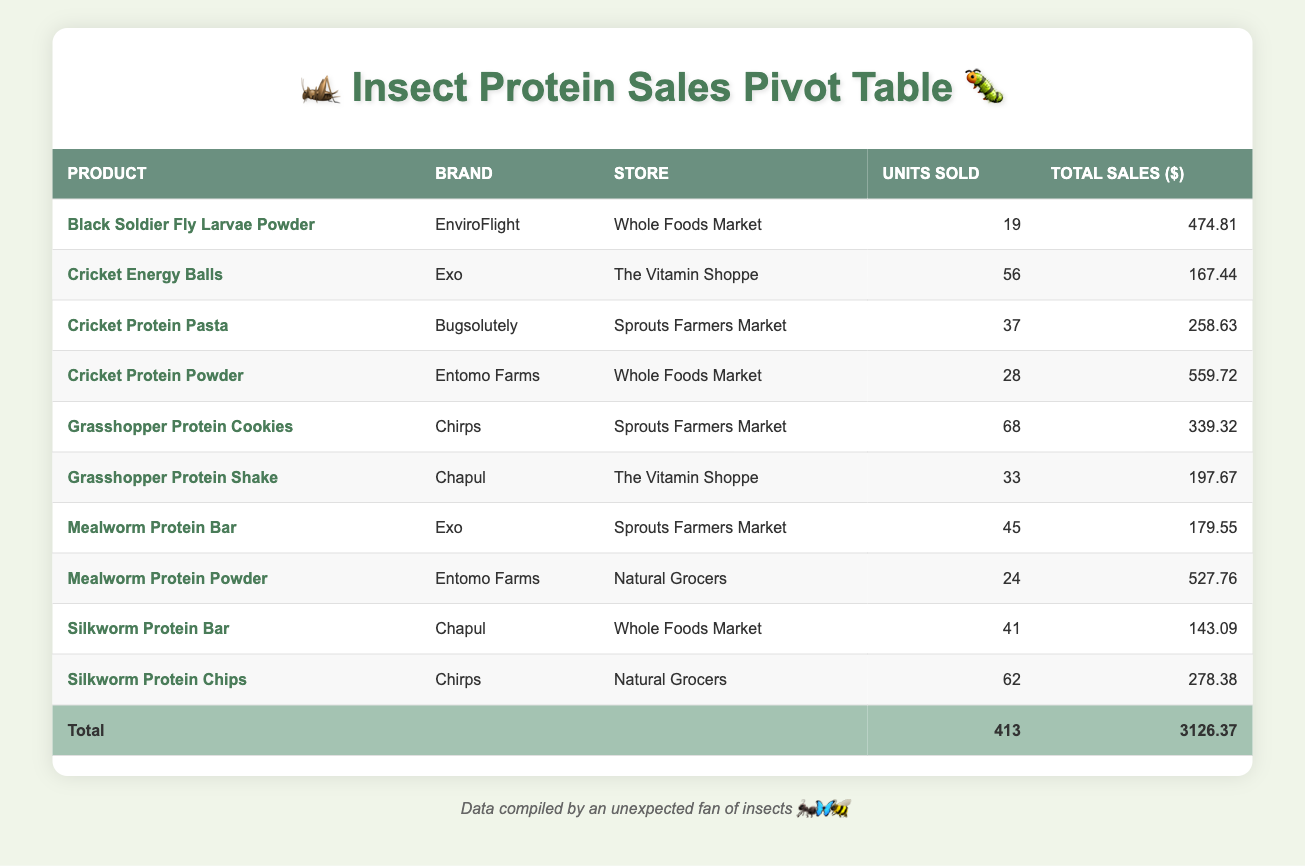What is the total sales amount for "Cricket Protein Powder"? The total sales figure for "Cricket Protein Powder" can be found directly in the table, where it states "Cricket Protein Powder" under the product column with its corresponding total sales of $559.72.
Answer: 559.72 Which product had the highest total sales? To find the product with the highest total sales, we need to look through the total sales column. By comparing each total sales figure, "Cricket Protein Powder" has the highest value of $559.72.
Answer: Cricket Protein Powder How many units of "Mealworm Protein Bar" were sold at "Sprouts Farmers Market"? From the table, by locating "Mealworm Protein Bar" under the product column, we can see that there were 45 units sold listed next to it under the units sold column for "Sprouts Farmers Market".
Answer: 45 What is the average price of products sold at "Whole Foods Market"? To calculate the average price, first, we identify the products sold at "Whole Foods Market" – "Cricket Protein Powder" ($19.99), "Black Soldier Fly Larvae Powder" ($24.99), and "Silkworm Protein Bar" ($3.49). Adding these prices gives $48.47, then dividing by 3 (the number of products) results in an average price of approximately $16.16.
Answer: 16.16 Did "Sprouts Farmers Market" sell more units of "Grasshopper Protein Cookies" than "Cricket Energy Balls"? Looking at the units sold for "Grasshopper Protein Cookies" (68) and "Cricket Energy Balls" (56) at "Sprouts Farmers Market," it is clear that more units were sold of "Grasshopper Protein Cookies". Therefore, the answer is yes.
Answer: Yes What was the total number of units sold across all products? To find the total units sold, we add up the units sold for each product: 28 + 45 + 62 + 33 + 19 + 37 + 24 + 56 + 41 + 68, which equals 413 units sold in total.
Answer: 413 What was the total sales amount for all products sold at "The Vitamin Shoppe"? The products sold at "The Vitamin Shoppe" are "Grasshopper Protein Shake" ($197.67) and "Cricket Energy Balls" ($167.44). By summing these amounts, 197.67 + 167.44 = 365.11, which shows the total sales for that store.
Answer: 365.11 Which age group purchased the highest number of products? From the data, we need to aggregate the units sold by age group. The numbers are as follows: 18-24: 62 + 56 = 118, 25-34: 28 + 24 + 68 = 120, 35-44: 45 + 37 = 82, 45-54: 33 + 41 = 74, and 55+: 19 = 19. Hence, the age group 25-34 purchased the most products with 120 units.
Answer: 25-34 Did any of the products have sales exceeding $500? By reviewing the total sales amounts for each product, we see that "Cricket Protein Powder" ($559.72) and "Mealworm Protein Powder" ($527.76) both have sales over $500. So, the answer is yes.
Answer: Yes 